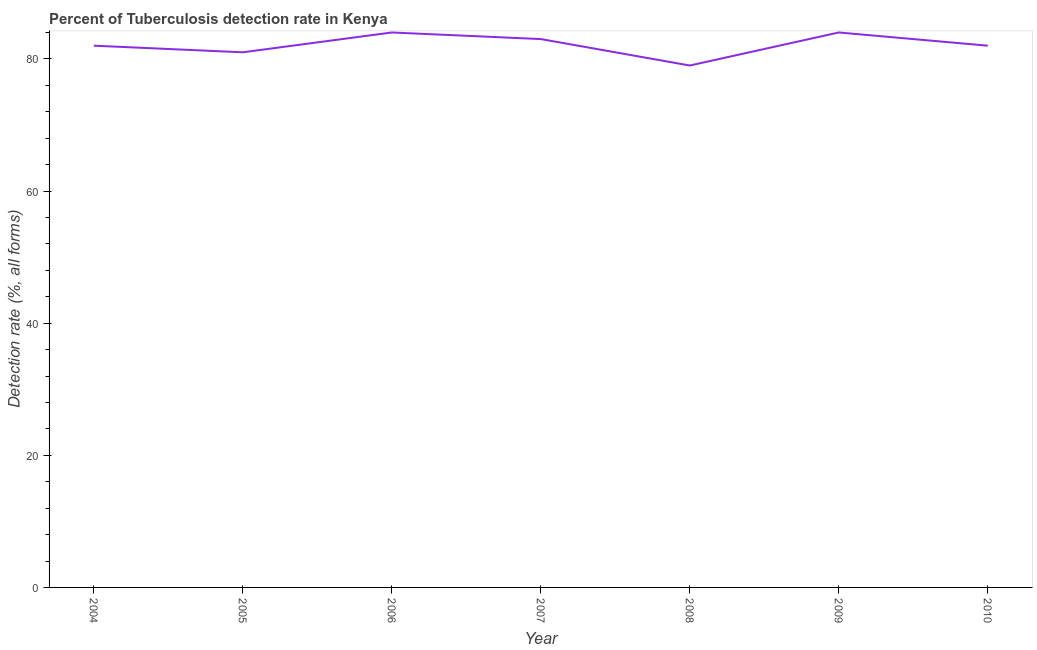What is the detection rate of tuberculosis in 2009?
Your answer should be compact. 84. Across all years, what is the maximum detection rate of tuberculosis?
Offer a terse response. 84. Across all years, what is the minimum detection rate of tuberculosis?
Make the answer very short. 79. In which year was the detection rate of tuberculosis minimum?
Offer a terse response. 2008. What is the sum of the detection rate of tuberculosis?
Provide a succinct answer. 575. What is the difference between the detection rate of tuberculosis in 2005 and 2008?
Make the answer very short. 2. What is the average detection rate of tuberculosis per year?
Keep it short and to the point. 82.14. What is the median detection rate of tuberculosis?
Offer a very short reply. 82. In how many years, is the detection rate of tuberculosis greater than 48 %?
Your answer should be very brief. 7. Do a majority of the years between 2009 and 2005 (inclusive) have detection rate of tuberculosis greater than 52 %?
Provide a succinct answer. Yes. What is the ratio of the detection rate of tuberculosis in 2004 to that in 2009?
Offer a terse response. 0.98. What is the difference between the highest and the second highest detection rate of tuberculosis?
Keep it short and to the point. 0. Is the sum of the detection rate of tuberculosis in 2004 and 2005 greater than the maximum detection rate of tuberculosis across all years?
Ensure brevity in your answer.  Yes. What is the difference between the highest and the lowest detection rate of tuberculosis?
Offer a terse response. 5. In how many years, is the detection rate of tuberculosis greater than the average detection rate of tuberculosis taken over all years?
Offer a very short reply. 3. Does the detection rate of tuberculosis monotonically increase over the years?
Keep it short and to the point. No. Are the values on the major ticks of Y-axis written in scientific E-notation?
Make the answer very short. No. Does the graph contain grids?
Your answer should be compact. No. What is the title of the graph?
Your answer should be very brief. Percent of Tuberculosis detection rate in Kenya. What is the label or title of the Y-axis?
Give a very brief answer. Detection rate (%, all forms). What is the Detection rate (%, all forms) in 2004?
Provide a short and direct response. 82. What is the Detection rate (%, all forms) of 2005?
Offer a terse response. 81. What is the Detection rate (%, all forms) of 2007?
Keep it short and to the point. 83. What is the Detection rate (%, all forms) of 2008?
Your answer should be very brief. 79. What is the difference between the Detection rate (%, all forms) in 2004 and 2005?
Provide a short and direct response. 1. What is the difference between the Detection rate (%, all forms) in 2004 and 2006?
Make the answer very short. -2. What is the difference between the Detection rate (%, all forms) in 2004 and 2008?
Offer a very short reply. 3. What is the difference between the Detection rate (%, all forms) in 2004 and 2009?
Keep it short and to the point. -2. What is the difference between the Detection rate (%, all forms) in 2005 and 2006?
Provide a succinct answer. -3. What is the difference between the Detection rate (%, all forms) in 2005 and 2008?
Provide a succinct answer. 2. What is the difference between the Detection rate (%, all forms) in 2005 and 2009?
Ensure brevity in your answer.  -3. What is the difference between the Detection rate (%, all forms) in 2005 and 2010?
Ensure brevity in your answer.  -1. What is the difference between the Detection rate (%, all forms) in 2006 and 2007?
Ensure brevity in your answer.  1. What is the difference between the Detection rate (%, all forms) in 2006 and 2008?
Your answer should be compact. 5. What is the difference between the Detection rate (%, all forms) in 2006 and 2009?
Provide a short and direct response. 0. What is the difference between the Detection rate (%, all forms) in 2006 and 2010?
Your response must be concise. 2. What is the difference between the Detection rate (%, all forms) in 2007 and 2008?
Make the answer very short. 4. What is the difference between the Detection rate (%, all forms) in 2007 and 2009?
Your response must be concise. -1. What is the difference between the Detection rate (%, all forms) in 2008 and 2009?
Offer a terse response. -5. What is the difference between the Detection rate (%, all forms) in 2009 and 2010?
Provide a short and direct response. 2. What is the ratio of the Detection rate (%, all forms) in 2004 to that in 2006?
Provide a short and direct response. 0.98. What is the ratio of the Detection rate (%, all forms) in 2004 to that in 2008?
Offer a very short reply. 1.04. What is the ratio of the Detection rate (%, all forms) in 2005 to that in 2007?
Your answer should be compact. 0.98. What is the ratio of the Detection rate (%, all forms) in 2005 to that in 2008?
Provide a succinct answer. 1.02. What is the ratio of the Detection rate (%, all forms) in 2006 to that in 2007?
Ensure brevity in your answer.  1.01. What is the ratio of the Detection rate (%, all forms) in 2006 to that in 2008?
Make the answer very short. 1.06. What is the ratio of the Detection rate (%, all forms) in 2007 to that in 2008?
Keep it short and to the point. 1.05. What is the ratio of the Detection rate (%, all forms) in 2007 to that in 2009?
Offer a terse response. 0.99. What is the ratio of the Detection rate (%, all forms) in 2007 to that in 2010?
Offer a terse response. 1.01. 